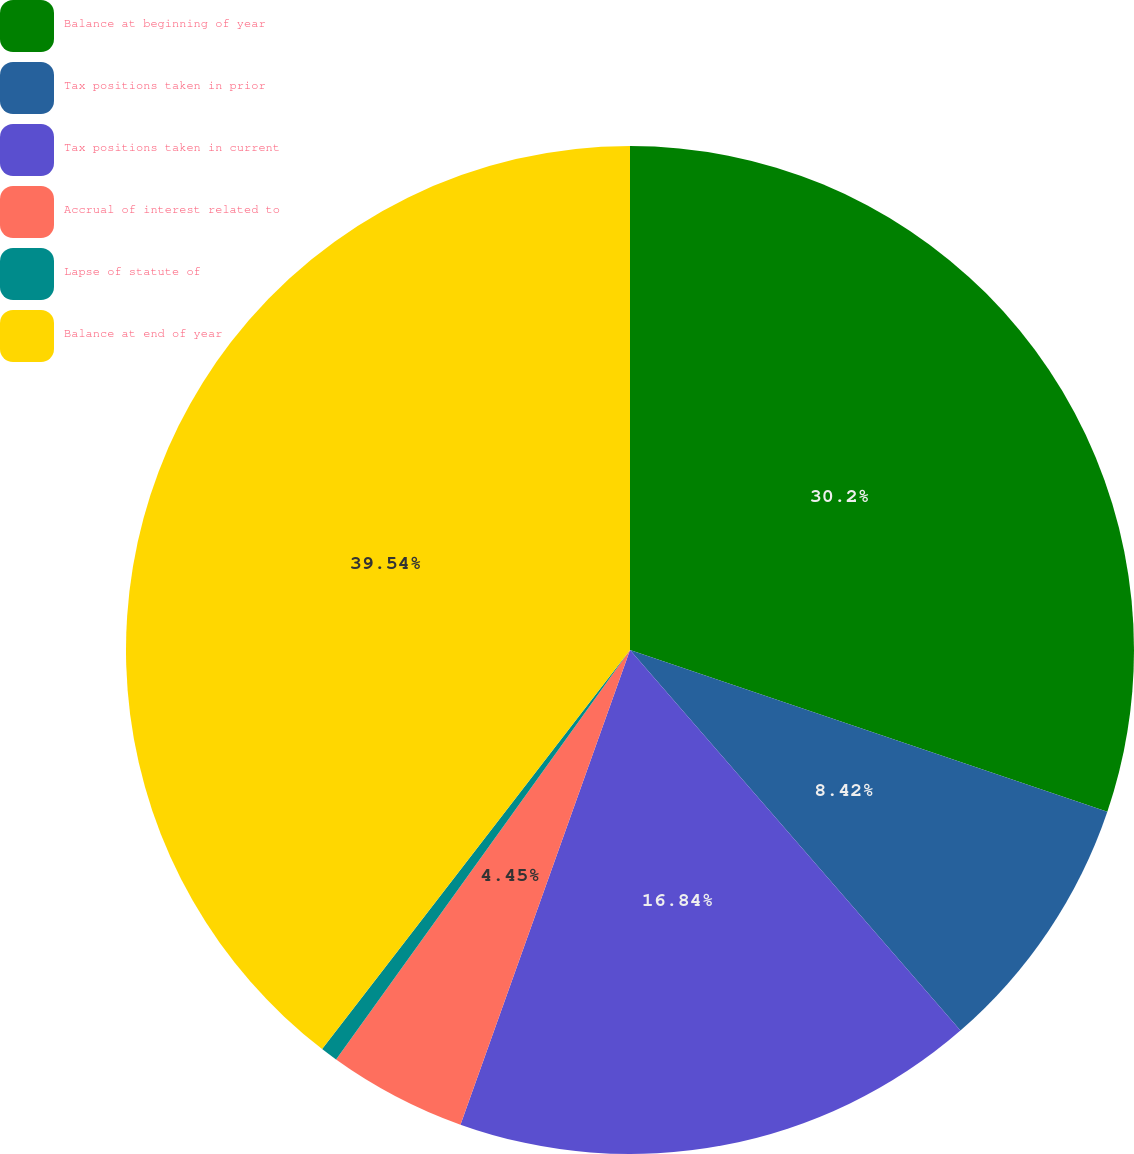Convert chart to OTSL. <chart><loc_0><loc_0><loc_500><loc_500><pie_chart><fcel>Balance at beginning of year<fcel>Tax positions taken in prior<fcel>Tax positions taken in current<fcel>Accrual of interest related to<fcel>Lapse of statute of<fcel>Balance at end of year<nl><fcel>30.2%<fcel>8.42%<fcel>16.84%<fcel>4.45%<fcel>0.55%<fcel>39.54%<nl></chart> 